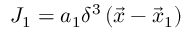Convert formula to latex. <formula><loc_0><loc_0><loc_500><loc_500>J _ { 1 } = a _ { 1 } \delta ^ { 3 } \left ( { \vec { x } } - { \vec { x } } _ { 1 } \right )</formula> 